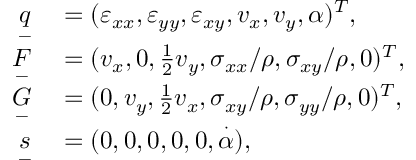Convert formula to latex. <formula><loc_0><loc_0><loc_500><loc_500>\begin{array} { r l } { \underset { - } { q } } & = ( \varepsilon _ { x x } , \varepsilon _ { y y } , \varepsilon _ { x y } , v _ { x } , v _ { y } , \alpha ) ^ { T } , } \\ { \underset { - } { F } } & = ( v _ { x } , 0 , \frac { 1 } { 2 } v _ { y } , \sigma _ { x x } / \rho , \sigma _ { x y } / \rho , 0 ) ^ { T } , } \\ { \underset { - } { G } } & = ( 0 , v _ { y } , \frac { 1 } { 2 } v _ { x } , \sigma _ { x y } / \rho , \sigma _ { y y } / \rho , 0 ) ^ { T } , } \\ { \underset { - } { s } } & = ( 0 , 0 , 0 , 0 , 0 , \overset { \cdot } { \alpha } ) , } \end{array}</formula> 